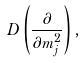<formula> <loc_0><loc_0><loc_500><loc_500>D \left ( \frac { \partial } { \partial m _ { j } ^ { 2 } } \right ) ,</formula> 